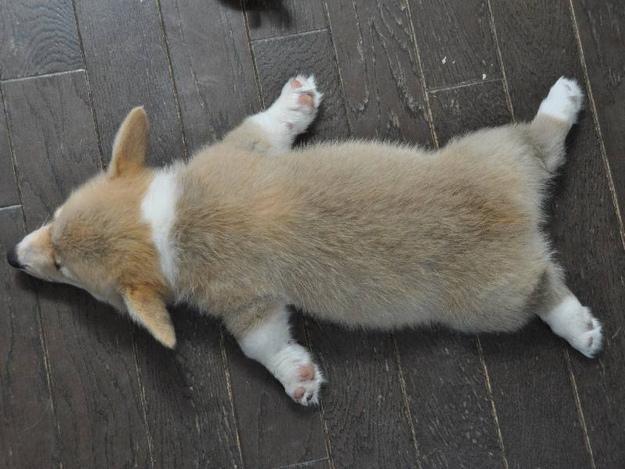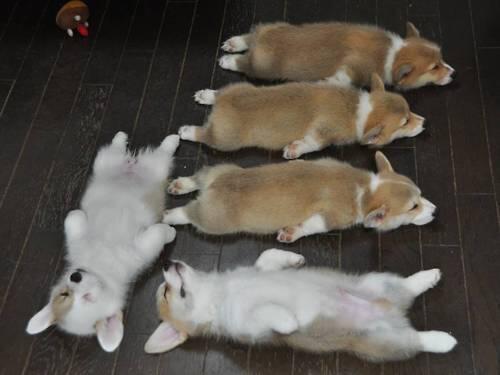The first image is the image on the left, the second image is the image on the right. Examine the images to the left and right. Is the description "All of the dogs are lying down, either on their bellies or on their backs, but not on their side." accurate? Answer yes or no. Yes. The first image is the image on the left, the second image is the image on the right. Considering the images on both sides, is "There are at least 5 dogs lying on the floor." valid? Answer yes or no. Yes. 